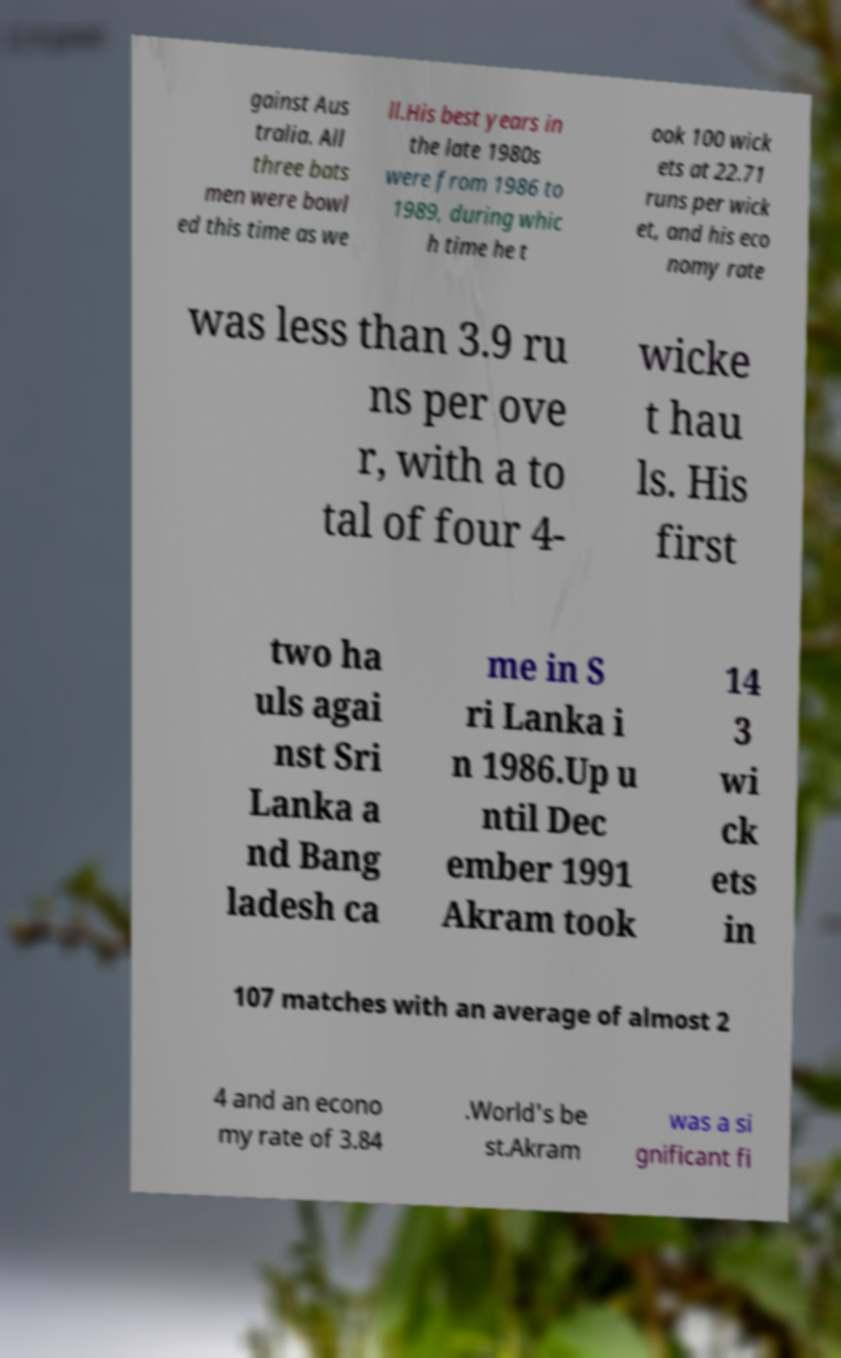Could you extract and type out the text from this image? gainst Aus tralia. All three bats men were bowl ed this time as we ll.His best years in the late 1980s were from 1986 to 1989, during whic h time he t ook 100 wick ets at 22.71 runs per wick et, and his eco nomy rate was less than 3.9 ru ns per ove r, with a to tal of four 4- wicke t hau ls. His first two ha uls agai nst Sri Lanka a nd Bang ladesh ca me in S ri Lanka i n 1986.Up u ntil Dec ember 1991 Akram took 14 3 wi ck ets in 107 matches with an average of almost 2 4 and an econo my rate of 3.84 .World's be st.Akram was a si gnificant fi 